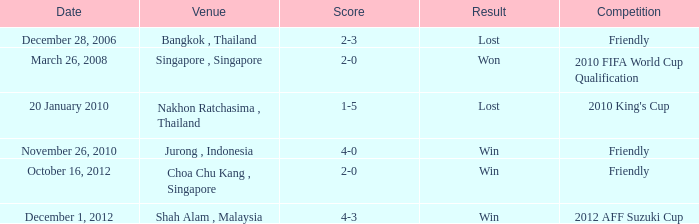Name the venue for friendly competition october 16, 2012 Choa Chu Kang , Singapore. 